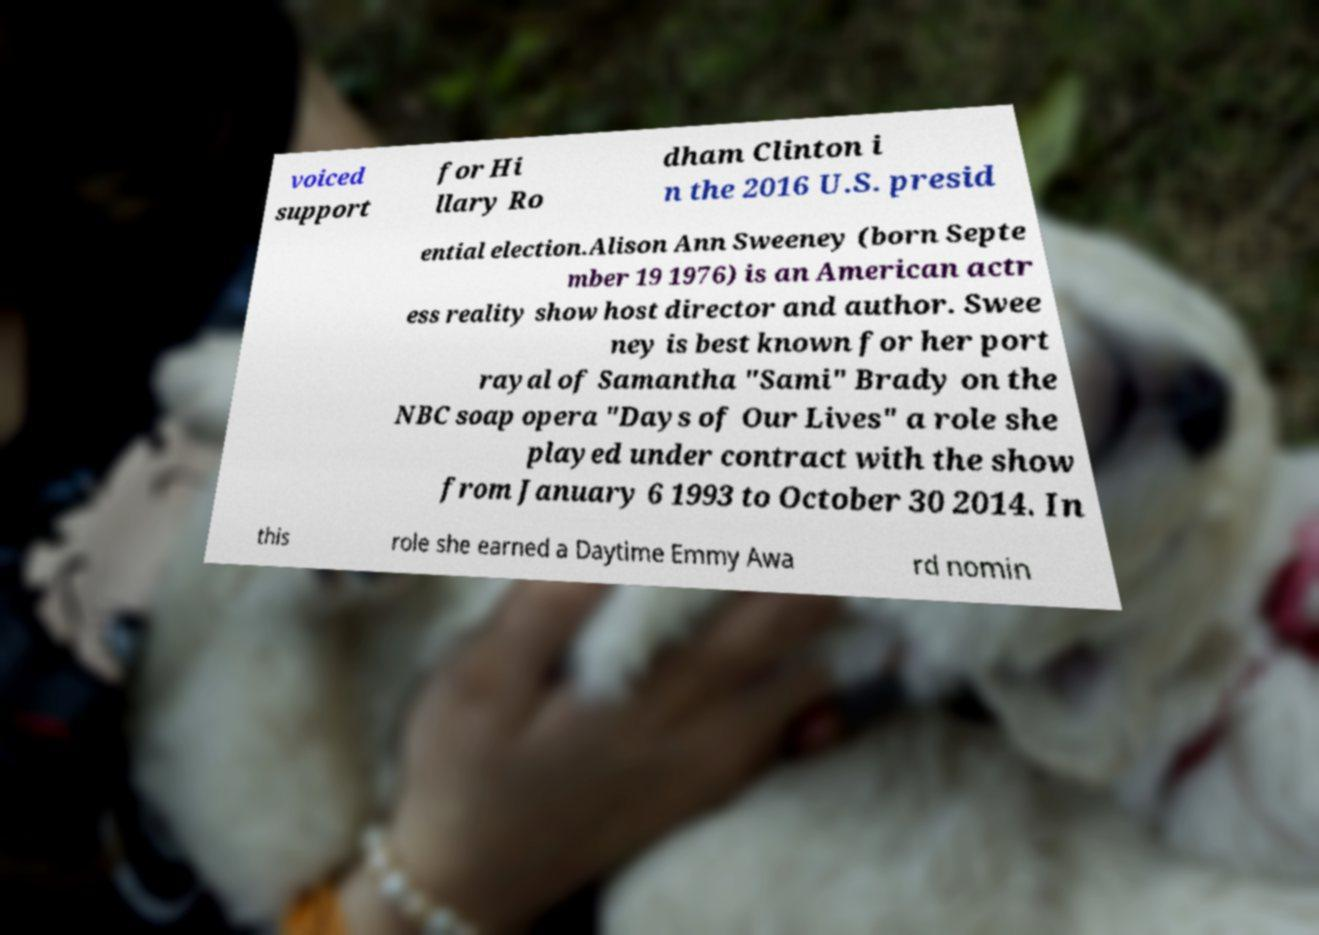What messages or text are displayed in this image? I need them in a readable, typed format. voiced support for Hi llary Ro dham Clinton i n the 2016 U.S. presid ential election.Alison Ann Sweeney (born Septe mber 19 1976) is an American actr ess reality show host director and author. Swee ney is best known for her port rayal of Samantha "Sami" Brady on the NBC soap opera "Days of Our Lives" a role she played under contract with the show from January 6 1993 to October 30 2014. In this role she earned a Daytime Emmy Awa rd nomin 